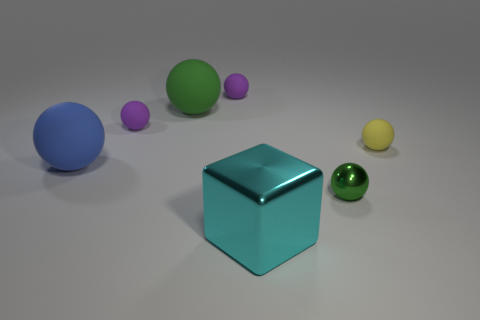Subtract all big spheres. How many spheres are left? 4 Subtract all green spheres. How many spheres are left? 4 Subtract 1 balls. How many balls are left? 5 Subtract all yellow spheres. Subtract all blue blocks. How many spheres are left? 5 Add 2 shiny cubes. How many objects exist? 9 Subtract all spheres. How many objects are left? 1 Subtract all blue shiny objects. Subtract all yellow rubber objects. How many objects are left? 6 Add 6 tiny purple objects. How many tiny purple objects are left? 8 Add 1 green matte objects. How many green matte objects exist? 2 Subtract 0 brown cylinders. How many objects are left? 7 